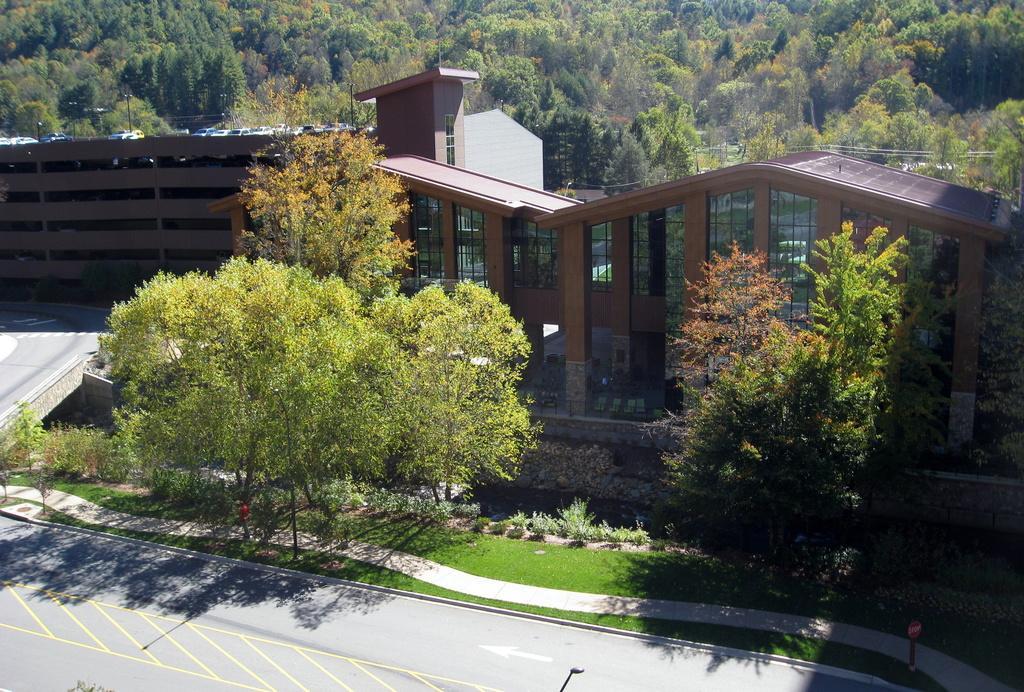Please provide a concise description of this image. In this picture I can see buildings, trees and few plants. 